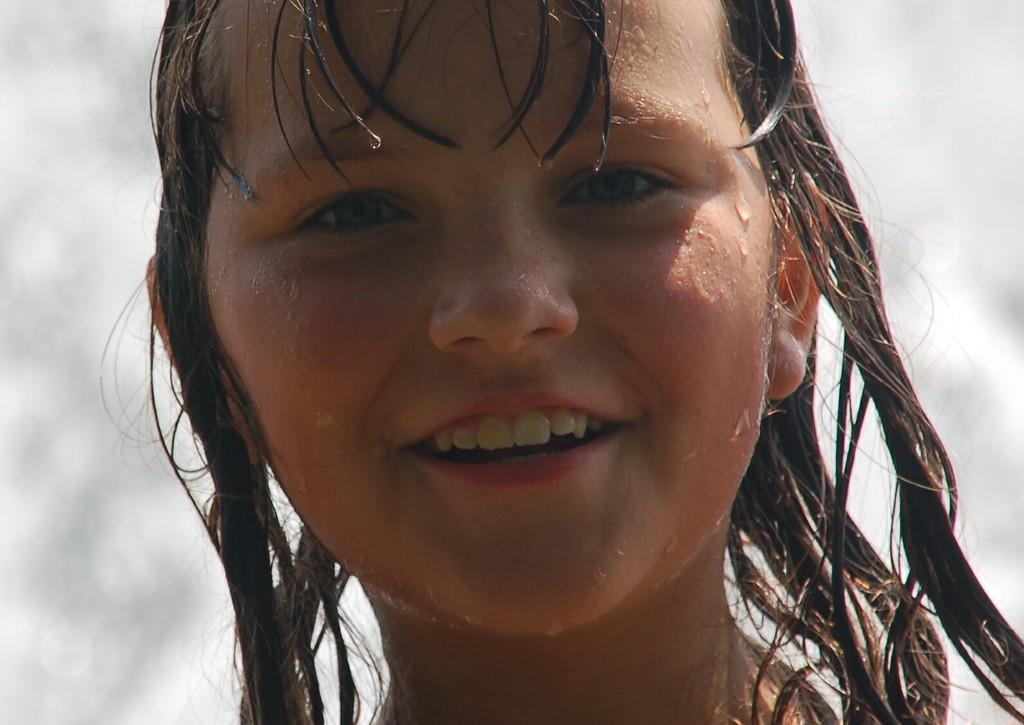Who is the main subject in the image? There is a girl in the image. What can be seen on the girl's face? The girl's face is visible, and she is smiling. What is the condition of the girl's hair and face? There is water on the girl's face and hair. What colors are present in the background of the image? The background of the image is white and grey. What type of activity is the girl participating in at the church in the image? There is no church or activity present in the image; it features a girl with water on her face and hair. 